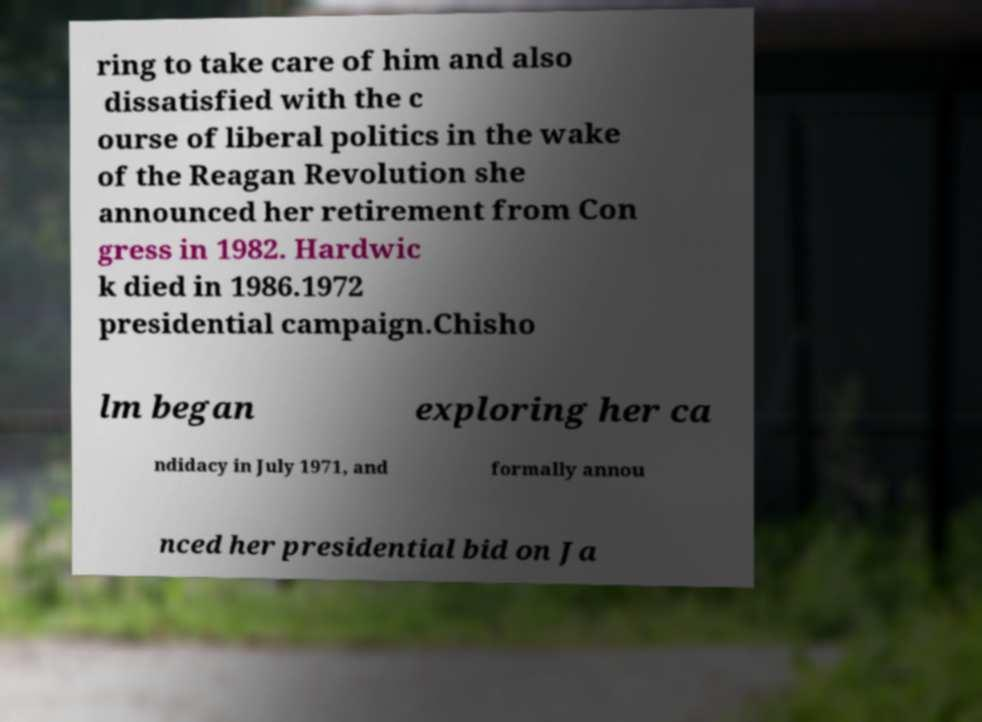Can you accurately transcribe the text from the provided image for me? ring to take care of him and also dissatisfied with the c ourse of liberal politics in the wake of the Reagan Revolution she announced her retirement from Con gress in 1982. Hardwic k died in 1986.1972 presidential campaign.Chisho lm began exploring her ca ndidacy in July 1971, and formally annou nced her presidential bid on Ja 